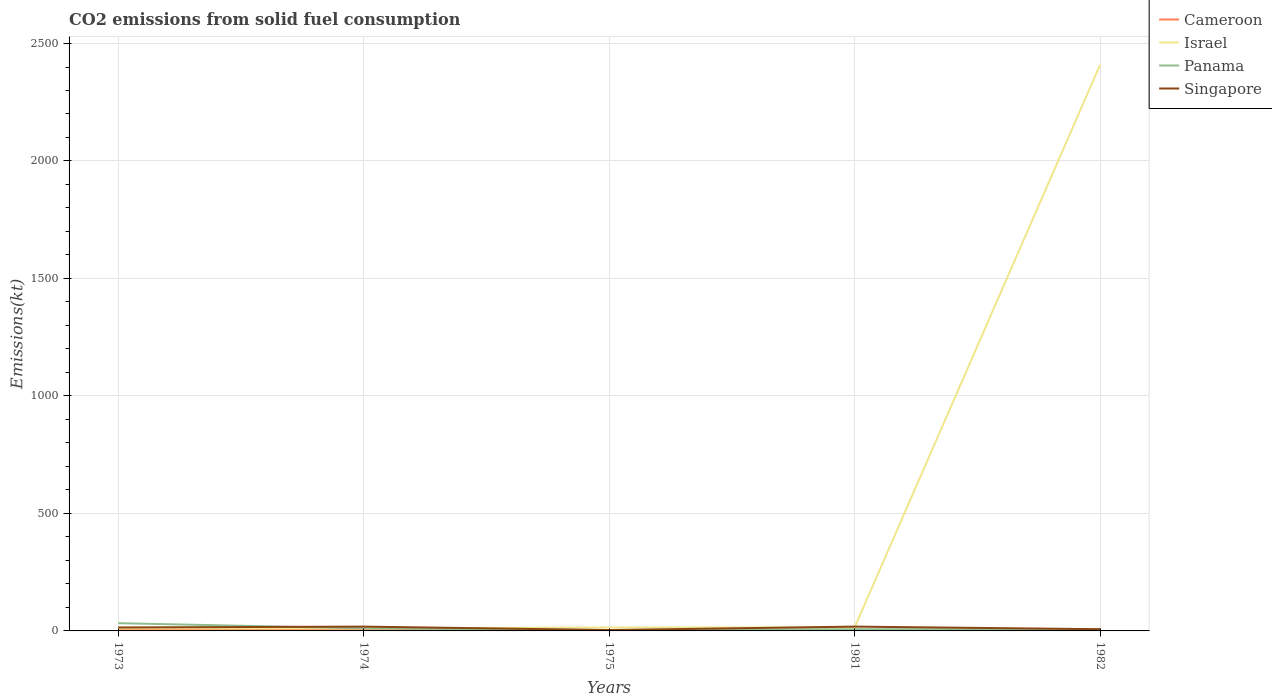Does the line corresponding to Israel intersect with the line corresponding to Cameroon?
Give a very brief answer. No. Across all years, what is the maximum amount of CO2 emitted in Panama?
Provide a succinct answer. 3.67. In which year was the amount of CO2 emitted in Singapore maximum?
Offer a terse response. 1975. What is the total amount of CO2 emitted in Singapore in the graph?
Keep it short and to the point. 11. What is the difference between the highest and the second highest amount of CO2 emitted in Israel?
Ensure brevity in your answer.  2398.22. How many lines are there?
Give a very brief answer. 4. Are the values on the major ticks of Y-axis written in scientific E-notation?
Provide a short and direct response. No. Does the graph contain any zero values?
Your answer should be compact. No. Does the graph contain grids?
Provide a short and direct response. Yes. What is the title of the graph?
Your answer should be very brief. CO2 emissions from solid fuel consumption. What is the label or title of the X-axis?
Offer a terse response. Years. What is the label or title of the Y-axis?
Make the answer very short. Emissions(kt). What is the Emissions(kt) of Cameroon in 1973?
Your answer should be very brief. 3.67. What is the Emissions(kt) of Israel in 1973?
Ensure brevity in your answer.  11. What is the Emissions(kt) of Panama in 1973?
Ensure brevity in your answer.  33. What is the Emissions(kt) of Singapore in 1973?
Keep it short and to the point. 14.67. What is the Emissions(kt) of Cameroon in 1974?
Provide a succinct answer. 3.67. What is the Emissions(kt) of Israel in 1974?
Ensure brevity in your answer.  11. What is the Emissions(kt) in Panama in 1974?
Make the answer very short. 11. What is the Emissions(kt) in Singapore in 1974?
Offer a very short reply. 18.34. What is the Emissions(kt) of Cameroon in 1975?
Ensure brevity in your answer.  3.67. What is the Emissions(kt) of Israel in 1975?
Provide a succinct answer. 14.67. What is the Emissions(kt) in Panama in 1975?
Your answer should be compact. 3.67. What is the Emissions(kt) of Singapore in 1975?
Your answer should be compact. 3.67. What is the Emissions(kt) of Cameroon in 1981?
Keep it short and to the point. 3.67. What is the Emissions(kt) in Israel in 1981?
Give a very brief answer. 14.67. What is the Emissions(kt) of Panama in 1981?
Your answer should be compact. 7.33. What is the Emissions(kt) in Singapore in 1981?
Offer a very short reply. 18.34. What is the Emissions(kt) in Cameroon in 1982?
Your response must be concise. 3.67. What is the Emissions(kt) of Israel in 1982?
Keep it short and to the point. 2409.22. What is the Emissions(kt) in Panama in 1982?
Keep it short and to the point. 7.33. What is the Emissions(kt) in Singapore in 1982?
Make the answer very short. 7.33. Across all years, what is the maximum Emissions(kt) in Cameroon?
Your answer should be very brief. 3.67. Across all years, what is the maximum Emissions(kt) of Israel?
Give a very brief answer. 2409.22. Across all years, what is the maximum Emissions(kt) in Panama?
Keep it short and to the point. 33. Across all years, what is the maximum Emissions(kt) of Singapore?
Your answer should be very brief. 18.34. Across all years, what is the minimum Emissions(kt) of Cameroon?
Ensure brevity in your answer.  3.67. Across all years, what is the minimum Emissions(kt) in Israel?
Offer a very short reply. 11. Across all years, what is the minimum Emissions(kt) in Panama?
Give a very brief answer. 3.67. Across all years, what is the minimum Emissions(kt) in Singapore?
Give a very brief answer. 3.67. What is the total Emissions(kt) of Cameroon in the graph?
Offer a terse response. 18.34. What is the total Emissions(kt) in Israel in the graph?
Your answer should be compact. 2460.56. What is the total Emissions(kt) of Panama in the graph?
Provide a short and direct response. 62.34. What is the total Emissions(kt) of Singapore in the graph?
Provide a succinct answer. 62.34. What is the difference between the Emissions(kt) in Panama in 1973 and that in 1974?
Provide a succinct answer. 22. What is the difference between the Emissions(kt) in Singapore in 1973 and that in 1974?
Your response must be concise. -3.67. What is the difference between the Emissions(kt) of Israel in 1973 and that in 1975?
Offer a very short reply. -3.67. What is the difference between the Emissions(kt) of Panama in 1973 and that in 1975?
Give a very brief answer. 29.34. What is the difference between the Emissions(kt) in Singapore in 1973 and that in 1975?
Your response must be concise. 11. What is the difference between the Emissions(kt) of Israel in 1973 and that in 1981?
Provide a short and direct response. -3.67. What is the difference between the Emissions(kt) of Panama in 1973 and that in 1981?
Provide a short and direct response. 25.67. What is the difference between the Emissions(kt) in Singapore in 1973 and that in 1981?
Offer a terse response. -3.67. What is the difference between the Emissions(kt) of Cameroon in 1973 and that in 1982?
Give a very brief answer. 0. What is the difference between the Emissions(kt) in Israel in 1973 and that in 1982?
Make the answer very short. -2398.22. What is the difference between the Emissions(kt) of Panama in 1973 and that in 1982?
Ensure brevity in your answer.  25.67. What is the difference between the Emissions(kt) in Singapore in 1973 and that in 1982?
Your response must be concise. 7.33. What is the difference between the Emissions(kt) of Cameroon in 1974 and that in 1975?
Provide a succinct answer. 0. What is the difference between the Emissions(kt) in Israel in 1974 and that in 1975?
Your response must be concise. -3.67. What is the difference between the Emissions(kt) of Panama in 1974 and that in 1975?
Provide a short and direct response. 7.33. What is the difference between the Emissions(kt) in Singapore in 1974 and that in 1975?
Your response must be concise. 14.67. What is the difference between the Emissions(kt) in Israel in 1974 and that in 1981?
Provide a short and direct response. -3.67. What is the difference between the Emissions(kt) in Panama in 1974 and that in 1981?
Your answer should be compact. 3.67. What is the difference between the Emissions(kt) in Singapore in 1974 and that in 1981?
Your answer should be compact. 0. What is the difference between the Emissions(kt) in Israel in 1974 and that in 1982?
Your response must be concise. -2398.22. What is the difference between the Emissions(kt) in Panama in 1974 and that in 1982?
Make the answer very short. 3.67. What is the difference between the Emissions(kt) of Singapore in 1974 and that in 1982?
Provide a succinct answer. 11. What is the difference between the Emissions(kt) in Cameroon in 1975 and that in 1981?
Give a very brief answer. 0. What is the difference between the Emissions(kt) in Panama in 1975 and that in 1981?
Give a very brief answer. -3.67. What is the difference between the Emissions(kt) in Singapore in 1975 and that in 1981?
Your response must be concise. -14.67. What is the difference between the Emissions(kt) in Israel in 1975 and that in 1982?
Ensure brevity in your answer.  -2394.55. What is the difference between the Emissions(kt) in Panama in 1975 and that in 1982?
Offer a terse response. -3.67. What is the difference between the Emissions(kt) in Singapore in 1975 and that in 1982?
Ensure brevity in your answer.  -3.67. What is the difference between the Emissions(kt) of Cameroon in 1981 and that in 1982?
Offer a very short reply. 0. What is the difference between the Emissions(kt) in Israel in 1981 and that in 1982?
Make the answer very short. -2394.55. What is the difference between the Emissions(kt) of Panama in 1981 and that in 1982?
Make the answer very short. 0. What is the difference between the Emissions(kt) of Singapore in 1981 and that in 1982?
Offer a terse response. 11. What is the difference between the Emissions(kt) in Cameroon in 1973 and the Emissions(kt) in Israel in 1974?
Keep it short and to the point. -7.33. What is the difference between the Emissions(kt) of Cameroon in 1973 and the Emissions(kt) of Panama in 1974?
Provide a short and direct response. -7.33. What is the difference between the Emissions(kt) of Cameroon in 1973 and the Emissions(kt) of Singapore in 1974?
Your answer should be very brief. -14.67. What is the difference between the Emissions(kt) in Israel in 1973 and the Emissions(kt) in Panama in 1974?
Offer a terse response. 0. What is the difference between the Emissions(kt) of Israel in 1973 and the Emissions(kt) of Singapore in 1974?
Offer a very short reply. -7.33. What is the difference between the Emissions(kt) in Panama in 1973 and the Emissions(kt) in Singapore in 1974?
Your answer should be very brief. 14.67. What is the difference between the Emissions(kt) in Cameroon in 1973 and the Emissions(kt) in Israel in 1975?
Your answer should be very brief. -11. What is the difference between the Emissions(kt) of Israel in 1973 and the Emissions(kt) of Panama in 1975?
Your answer should be compact. 7.33. What is the difference between the Emissions(kt) of Israel in 1973 and the Emissions(kt) of Singapore in 1975?
Your answer should be compact. 7.33. What is the difference between the Emissions(kt) of Panama in 1973 and the Emissions(kt) of Singapore in 1975?
Your response must be concise. 29.34. What is the difference between the Emissions(kt) in Cameroon in 1973 and the Emissions(kt) in Israel in 1981?
Provide a short and direct response. -11. What is the difference between the Emissions(kt) of Cameroon in 1973 and the Emissions(kt) of Panama in 1981?
Your answer should be compact. -3.67. What is the difference between the Emissions(kt) of Cameroon in 1973 and the Emissions(kt) of Singapore in 1981?
Your answer should be compact. -14.67. What is the difference between the Emissions(kt) of Israel in 1973 and the Emissions(kt) of Panama in 1981?
Make the answer very short. 3.67. What is the difference between the Emissions(kt) in Israel in 1973 and the Emissions(kt) in Singapore in 1981?
Provide a short and direct response. -7.33. What is the difference between the Emissions(kt) of Panama in 1973 and the Emissions(kt) of Singapore in 1981?
Offer a very short reply. 14.67. What is the difference between the Emissions(kt) of Cameroon in 1973 and the Emissions(kt) of Israel in 1982?
Offer a terse response. -2405.55. What is the difference between the Emissions(kt) of Cameroon in 1973 and the Emissions(kt) of Panama in 1982?
Provide a short and direct response. -3.67. What is the difference between the Emissions(kt) of Cameroon in 1973 and the Emissions(kt) of Singapore in 1982?
Keep it short and to the point. -3.67. What is the difference between the Emissions(kt) in Israel in 1973 and the Emissions(kt) in Panama in 1982?
Offer a very short reply. 3.67. What is the difference between the Emissions(kt) of Israel in 1973 and the Emissions(kt) of Singapore in 1982?
Offer a terse response. 3.67. What is the difference between the Emissions(kt) in Panama in 1973 and the Emissions(kt) in Singapore in 1982?
Offer a very short reply. 25.67. What is the difference between the Emissions(kt) in Cameroon in 1974 and the Emissions(kt) in Israel in 1975?
Offer a terse response. -11. What is the difference between the Emissions(kt) of Israel in 1974 and the Emissions(kt) of Panama in 1975?
Provide a succinct answer. 7.33. What is the difference between the Emissions(kt) in Israel in 1974 and the Emissions(kt) in Singapore in 1975?
Your answer should be compact. 7.33. What is the difference between the Emissions(kt) of Panama in 1974 and the Emissions(kt) of Singapore in 1975?
Offer a terse response. 7.33. What is the difference between the Emissions(kt) in Cameroon in 1974 and the Emissions(kt) in Israel in 1981?
Provide a succinct answer. -11. What is the difference between the Emissions(kt) of Cameroon in 1974 and the Emissions(kt) of Panama in 1981?
Keep it short and to the point. -3.67. What is the difference between the Emissions(kt) in Cameroon in 1974 and the Emissions(kt) in Singapore in 1981?
Keep it short and to the point. -14.67. What is the difference between the Emissions(kt) of Israel in 1974 and the Emissions(kt) of Panama in 1981?
Offer a very short reply. 3.67. What is the difference between the Emissions(kt) of Israel in 1974 and the Emissions(kt) of Singapore in 1981?
Provide a succinct answer. -7.33. What is the difference between the Emissions(kt) in Panama in 1974 and the Emissions(kt) in Singapore in 1981?
Offer a very short reply. -7.33. What is the difference between the Emissions(kt) in Cameroon in 1974 and the Emissions(kt) in Israel in 1982?
Your answer should be very brief. -2405.55. What is the difference between the Emissions(kt) in Cameroon in 1974 and the Emissions(kt) in Panama in 1982?
Offer a terse response. -3.67. What is the difference between the Emissions(kt) of Cameroon in 1974 and the Emissions(kt) of Singapore in 1982?
Provide a succinct answer. -3.67. What is the difference between the Emissions(kt) of Israel in 1974 and the Emissions(kt) of Panama in 1982?
Give a very brief answer. 3.67. What is the difference between the Emissions(kt) of Israel in 1974 and the Emissions(kt) of Singapore in 1982?
Keep it short and to the point. 3.67. What is the difference between the Emissions(kt) of Panama in 1974 and the Emissions(kt) of Singapore in 1982?
Your response must be concise. 3.67. What is the difference between the Emissions(kt) in Cameroon in 1975 and the Emissions(kt) in Israel in 1981?
Offer a terse response. -11. What is the difference between the Emissions(kt) of Cameroon in 1975 and the Emissions(kt) of Panama in 1981?
Keep it short and to the point. -3.67. What is the difference between the Emissions(kt) of Cameroon in 1975 and the Emissions(kt) of Singapore in 1981?
Give a very brief answer. -14.67. What is the difference between the Emissions(kt) in Israel in 1975 and the Emissions(kt) in Panama in 1981?
Offer a very short reply. 7.33. What is the difference between the Emissions(kt) of Israel in 1975 and the Emissions(kt) of Singapore in 1981?
Offer a very short reply. -3.67. What is the difference between the Emissions(kt) in Panama in 1975 and the Emissions(kt) in Singapore in 1981?
Give a very brief answer. -14.67. What is the difference between the Emissions(kt) of Cameroon in 1975 and the Emissions(kt) of Israel in 1982?
Your answer should be compact. -2405.55. What is the difference between the Emissions(kt) of Cameroon in 1975 and the Emissions(kt) of Panama in 1982?
Ensure brevity in your answer.  -3.67. What is the difference between the Emissions(kt) in Cameroon in 1975 and the Emissions(kt) in Singapore in 1982?
Offer a very short reply. -3.67. What is the difference between the Emissions(kt) in Israel in 1975 and the Emissions(kt) in Panama in 1982?
Make the answer very short. 7.33. What is the difference between the Emissions(kt) of Israel in 1975 and the Emissions(kt) of Singapore in 1982?
Offer a very short reply. 7.33. What is the difference between the Emissions(kt) in Panama in 1975 and the Emissions(kt) in Singapore in 1982?
Provide a succinct answer. -3.67. What is the difference between the Emissions(kt) of Cameroon in 1981 and the Emissions(kt) of Israel in 1982?
Your answer should be compact. -2405.55. What is the difference between the Emissions(kt) in Cameroon in 1981 and the Emissions(kt) in Panama in 1982?
Your response must be concise. -3.67. What is the difference between the Emissions(kt) of Cameroon in 1981 and the Emissions(kt) of Singapore in 1982?
Provide a succinct answer. -3.67. What is the difference between the Emissions(kt) of Israel in 1981 and the Emissions(kt) of Panama in 1982?
Provide a succinct answer. 7.33. What is the difference between the Emissions(kt) in Israel in 1981 and the Emissions(kt) in Singapore in 1982?
Offer a terse response. 7.33. What is the difference between the Emissions(kt) in Panama in 1981 and the Emissions(kt) in Singapore in 1982?
Provide a short and direct response. 0. What is the average Emissions(kt) in Cameroon per year?
Offer a very short reply. 3.67. What is the average Emissions(kt) in Israel per year?
Give a very brief answer. 492.11. What is the average Emissions(kt) of Panama per year?
Offer a terse response. 12.47. What is the average Emissions(kt) in Singapore per year?
Your response must be concise. 12.47. In the year 1973, what is the difference between the Emissions(kt) of Cameroon and Emissions(kt) of Israel?
Your answer should be compact. -7.33. In the year 1973, what is the difference between the Emissions(kt) in Cameroon and Emissions(kt) in Panama?
Offer a terse response. -29.34. In the year 1973, what is the difference between the Emissions(kt) in Cameroon and Emissions(kt) in Singapore?
Your answer should be compact. -11. In the year 1973, what is the difference between the Emissions(kt) in Israel and Emissions(kt) in Panama?
Your answer should be very brief. -22. In the year 1973, what is the difference between the Emissions(kt) of Israel and Emissions(kt) of Singapore?
Offer a terse response. -3.67. In the year 1973, what is the difference between the Emissions(kt) of Panama and Emissions(kt) of Singapore?
Offer a terse response. 18.34. In the year 1974, what is the difference between the Emissions(kt) in Cameroon and Emissions(kt) in Israel?
Make the answer very short. -7.33. In the year 1974, what is the difference between the Emissions(kt) in Cameroon and Emissions(kt) in Panama?
Provide a short and direct response. -7.33. In the year 1974, what is the difference between the Emissions(kt) of Cameroon and Emissions(kt) of Singapore?
Your answer should be compact. -14.67. In the year 1974, what is the difference between the Emissions(kt) in Israel and Emissions(kt) in Panama?
Offer a very short reply. 0. In the year 1974, what is the difference between the Emissions(kt) in Israel and Emissions(kt) in Singapore?
Give a very brief answer. -7.33. In the year 1974, what is the difference between the Emissions(kt) of Panama and Emissions(kt) of Singapore?
Make the answer very short. -7.33. In the year 1975, what is the difference between the Emissions(kt) of Cameroon and Emissions(kt) of Israel?
Your answer should be very brief. -11. In the year 1975, what is the difference between the Emissions(kt) of Cameroon and Emissions(kt) of Panama?
Provide a succinct answer. 0. In the year 1975, what is the difference between the Emissions(kt) of Cameroon and Emissions(kt) of Singapore?
Your answer should be compact. 0. In the year 1975, what is the difference between the Emissions(kt) of Israel and Emissions(kt) of Panama?
Provide a short and direct response. 11. In the year 1975, what is the difference between the Emissions(kt) in Israel and Emissions(kt) in Singapore?
Your answer should be very brief. 11. In the year 1981, what is the difference between the Emissions(kt) in Cameroon and Emissions(kt) in Israel?
Offer a terse response. -11. In the year 1981, what is the difference between the Emissions(kt) in Cameroon and Emissions(kt) in Panama?
Offer a very short reply. -3.67. In the year 1981, what is the difference between the Emissions(kt) in Cameroon and Emissions(kt) in Singapore?
Your answer should be very brief. -14.67. In the year 1981, what is the difference between the Emissions(kt) of Israel and Emissions(kt) of Panama?
Offer a terse response. 7.33. In the year 1981, what is the difference between the Emissions(kt) in Israel and Emissions(kt) in Singapore?
Offer a terse response. -3.67. In the year 1981, what is the difference between the Emissions(kt) of Panama and Emissions(kt) of Singapore?
Your response must be concise. -11. In the year 1982, what is the difference between the Emissions(kt) in Cameroon and Emissions(kt) in Israel?
Keep it short and to the point. -2405.55. In the year 1982, what is the difference between the Emissions(kt) in Cameroon and Emissions(kt) in Panama?
Offer a very short reply. -3.67. In the year 1982, what is the difference between the Emissions(kt) of Cameroon and Emissions(kt) of Singapore?
Your answer should be compact. -3.67. In the year 1982, what is the difference between the Emissions(kt) in Israel and Emissions(kt) in Panama?
Make the answer very short. 2401.89. In the year 1982, what is the difference between the Emissions(kt) of Israel and Emissions(kt) of Singapore?
Provide a short and direct response. 2401.89. What is the ratio of the Emissions(kt) in Singapore in 1973 to that in 1974?
Your response must be concise. 0.8. What is the ratio of the Emissions(kt) in Cameroon in 1973 to that in 1975?
Provide a short and direct response. 1. What is the ratio of the Emissions(kt) of Panama in 1973 to that in 1975?
Provide a succinct answer. 9. What is the ratio of the Emissions(kt) in Panama in 1973 to that in 1981?
Your answer should be very brief. 4.5. What is the ratio of the Emissions(kt) in Singapore in 1973 to that in 1981?
Ensure brevity in your answer.  0.8. What is the ratio of the Emissions(kt) in Israel in 1973 to that in 1982?
Make the answer very short. 0. What is the ratio of the Emissions(kt) of Panama in 1973 to that in 1982?
Offer a very short reply. 4.5. What is the ratio of the Emissions(kt) of Singapore in 1973 to that in 1982?
Give a very brief answer. 2. What is the ratio of the Emissions(kt) of Cameroon in 1974 to that in 1975?
Provide a succinct answer. 1. What is the ratio of the Emissions(kt) of Panama in 1974 to that in 1975?
Ensure brevity in your answer.  3. What is the ratio of the Emissions(kt) in Singapore in 1974 to that in 1981?
Provide a succinct answer. 1. What is the ratio of the Emissions(kt) of Israel in 1974 to that in 1982?
Your answer should be compact. 0. What is the ratio of the Emissions(kt) of Panama in 1974 to that in 1982?
Provide a short and direct response. 1.5. What is the ratio of the Emissions(kt) in Israel in 1975 to that in 1981?
Give a very brief answer. 1. What is the ratio of the Emissions(kt) of Israel in 1975 to that in 1982?
Your answer should be compact. 0.01. What is the ratio of the Emissions(kt) in Singapore in 1975 to that in 1982?
Your response must be concise. 0.5. What is the ratio of the Emissions(kt) in Cameroon in 1981 to that in 1982?
Keep it short and to the point. 1. What is the ratio of the Emissions(kt) of Israel in 1981 to that in 1982?
Offer a very short reply. 0.01. What is the difference between the highest and the second highest Emissions(kt) in Israel?
Your answer should be very brief. 2394.55. What is the difference between the highest and the second highest Emissions(kt) in Panama?
Your answer should be very brief. 22. What is the difference between the highest and the second highest Emissions(kt) of Singapore?
Your answer should be compact. 0. What is the difference between the highest and the lowest Emissions(kt) in Cameroon?
Provide a succinct answer. 0. What is the difference between the highest and the lowest Emissions(kt) in Israel?
Offer a very short reply. 2398.22. What is the difference between the highest and the lowest Emissions(kt) of Panama?
Your answer should be compact. 29.34. What is the difference between the highest and the lowest Emissions(kt) of Singapore?
Provide a succinct answer. 14.67. 